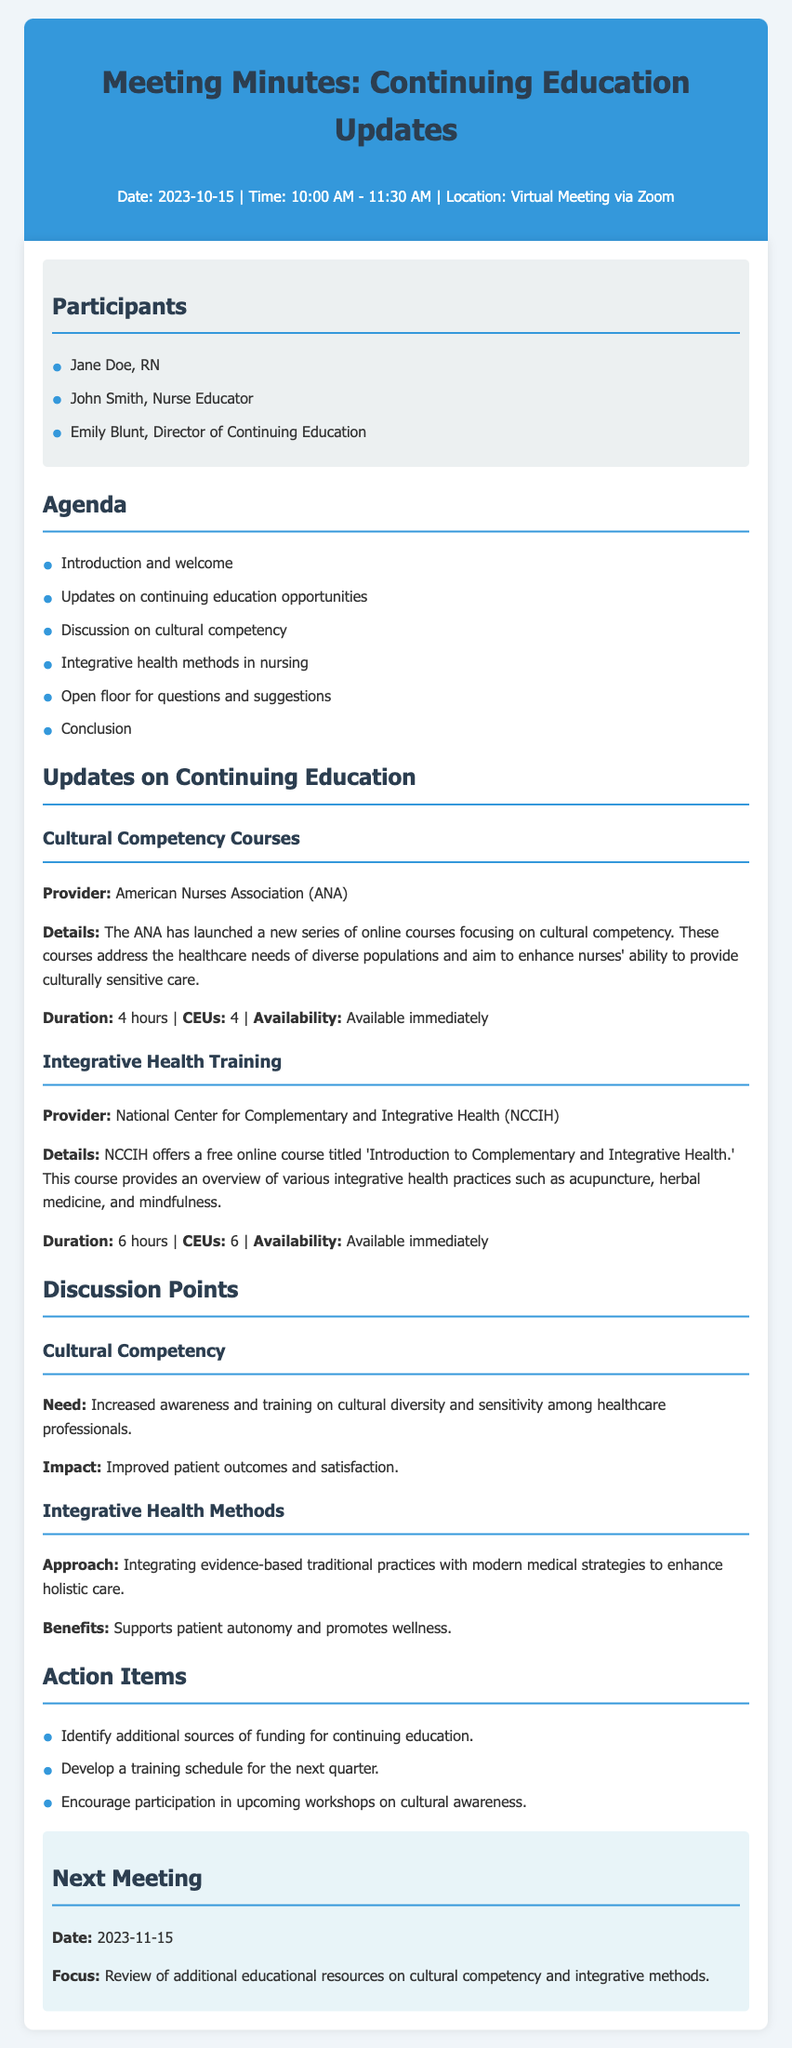What is the date of the meeting? The date is specified in the header section of the document.
Answer: 2023-10-15 Who is the provider of the cultural competency courses? The provider is mentioned in the updates section under cultural competency courses.
Answer: American Nurses Association What is the duration of the integrative health training course? The duration is noted in the updates section under integrative health training.
Answer: 6 hours What are the CEUs offered for the cultural competency courses? The CEUs are listed in the updates section under cultural competency courses.
Answer: 4 What is the main focus of the next meeting? The focus is specified in the next meeting section.
Answer: Review of additional educational resources on cultural competency and integrative methods What is one benefit of integrating evidence-based traditional practices? The benefit is detailed in the discussion section under integrative health methods.
Answer: Supports patient autonomy What is the total number of action items listed? The total is determined by counting the items in the action items section.
Answer: 3 What is the time duration for the cultural competency courses? The duration is mentioned in the updates section under cultural competency courses.
Answer: 4 hours What is the focus of the discussions held during the meeting? The focus is outlined in the discussion points section.
Answer: Cultural competency and integrative health methods 